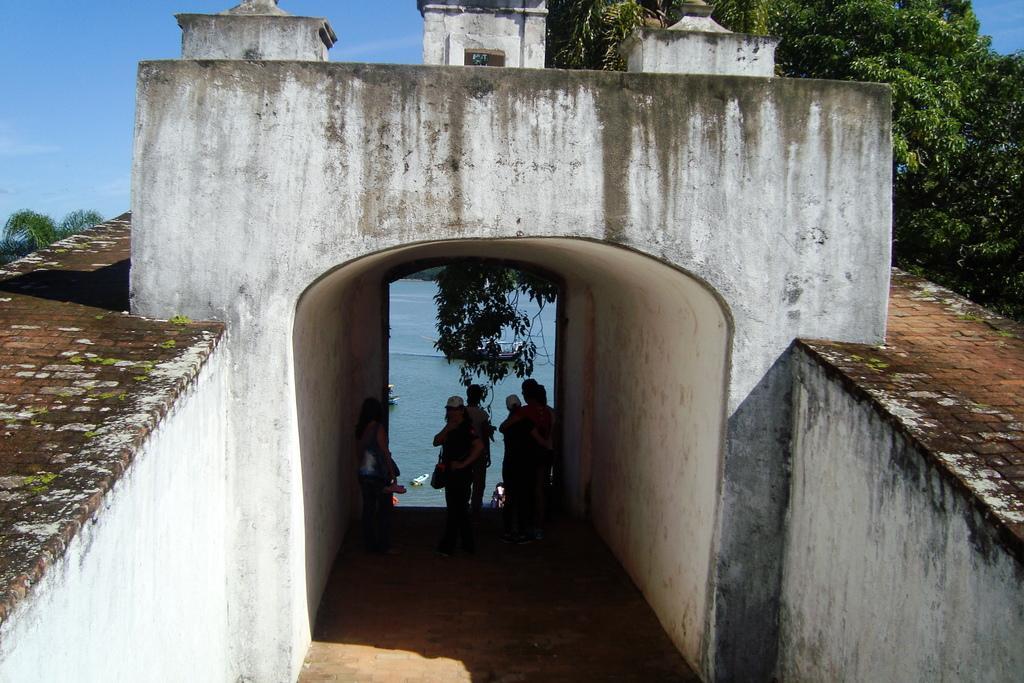Could you give a brief overview of what you see in this image? In this image, we can see people wearing clothes. There is an arch in the middle of the image. There are trees in the top right of the image. At the top of the image, we can see the sky. There is a wall in the bottom left and in the bottom right of the image. 